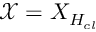<formula> <loc_0><loc_0><loc_500><loc_500>\mathcal { X } = { X } _ { H _ { c l } }</formula> 